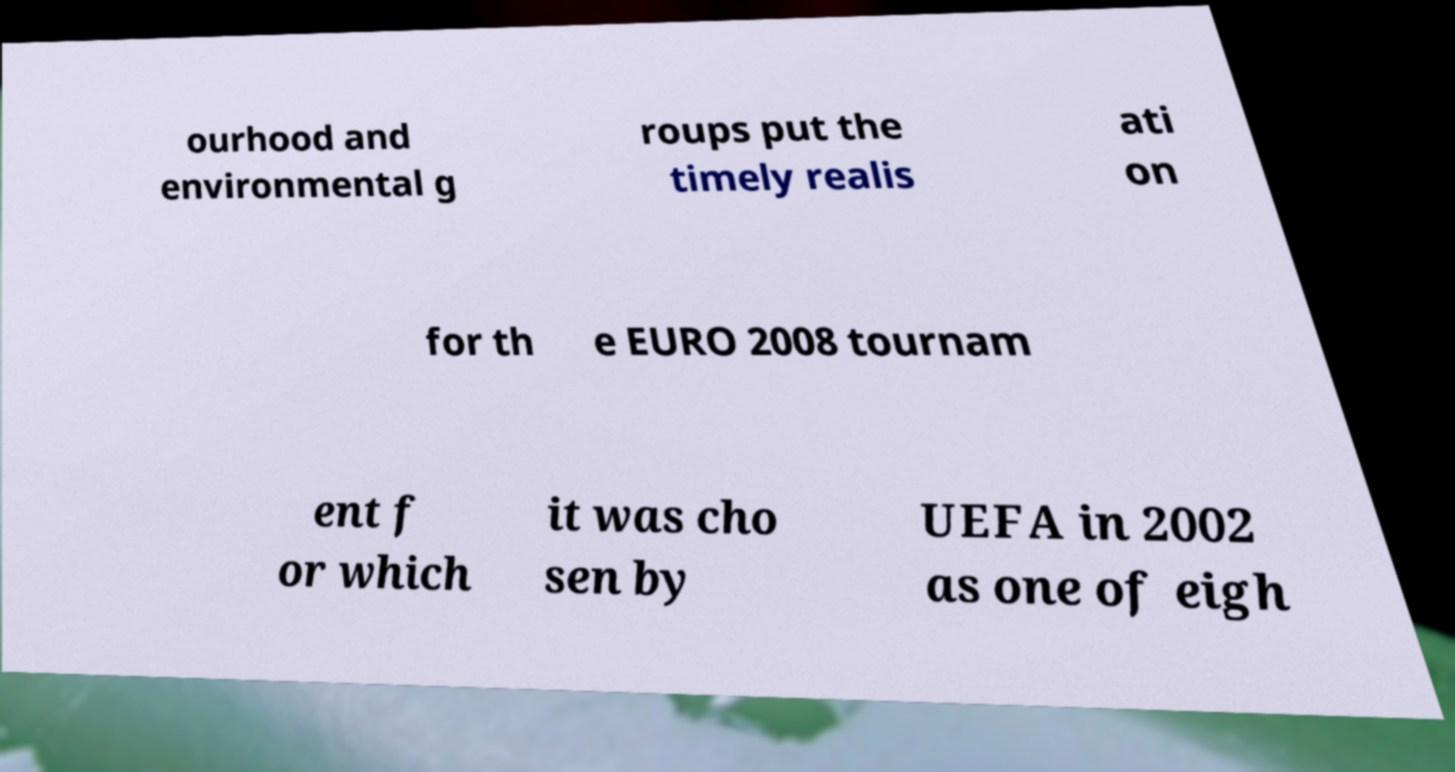For documentation purposes, I need the text within this image transcribed. Could you provide that? ourhood and environmental g roups put the timely realis ati on for th e EURO 2008 tournam ent f or which it was cho sen by UEFA in 2002 as one of eigh 